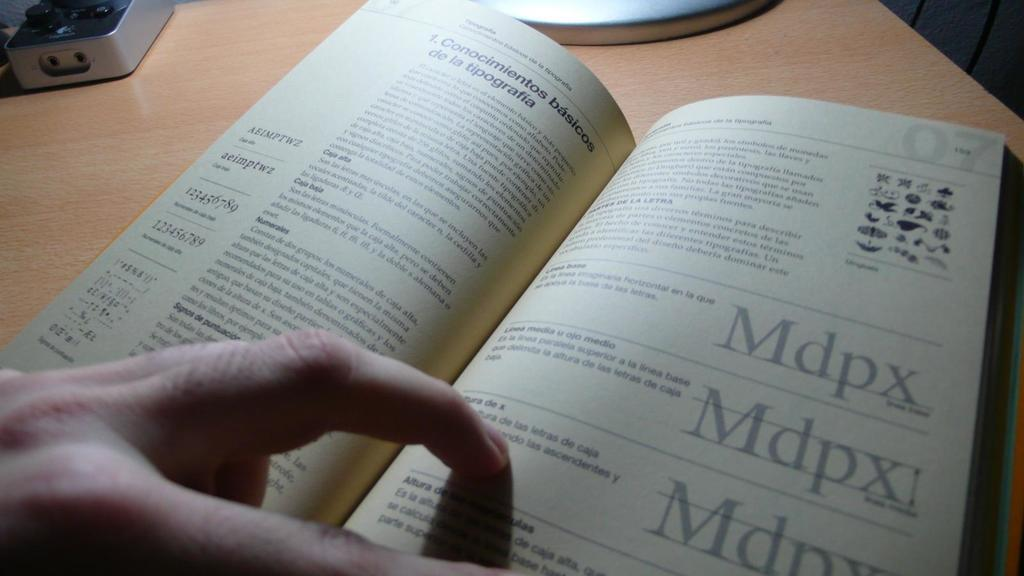<image>
Render a clear and concise summary of the photo. an open book to page 07 that says 'mdpx' on it three times 